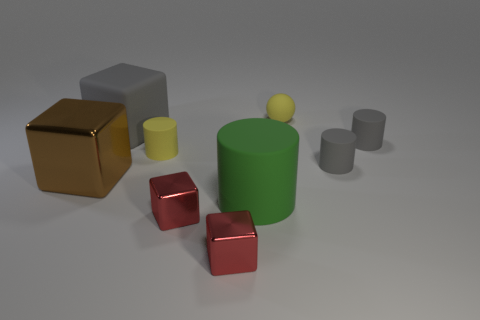The yellow sphere is what size?
Ensure brevity in your answer.  Small. How many brown objects are small cylinders or tiny metal spheres?
Offer a very short reply. 0. How many big gray rubber objects are the same shape as the brown metallic object?
Make the answer very short. 1. What number of red shiny cubes are the same size as the ball?
Provide a succinct answer. 2. There is another large object that is the same shape as the large shiny thing; what material is it?
Provide a succinct answer. Rubber. There is a small rubber object on the left side of the small yellow rubber ball; what is its color?
Provide a short and direct response. Yellow. Are there more brown cubes that are to the right of the yellow rubber ball than big brown things?
Offer a terse response. No. The large metal object has what color?
Make the answer very short. Brown. What is the shape of the yellow matte object that is to the left of the large rubber thing that is in front of the brown metal object that is to the left of the gray rubber cube?
Your answer should be compact. Cylinder. What is the big object that is both in front of the big gray object and on the left side of the large green thing made of?
Offer a very short reply. Metal. 